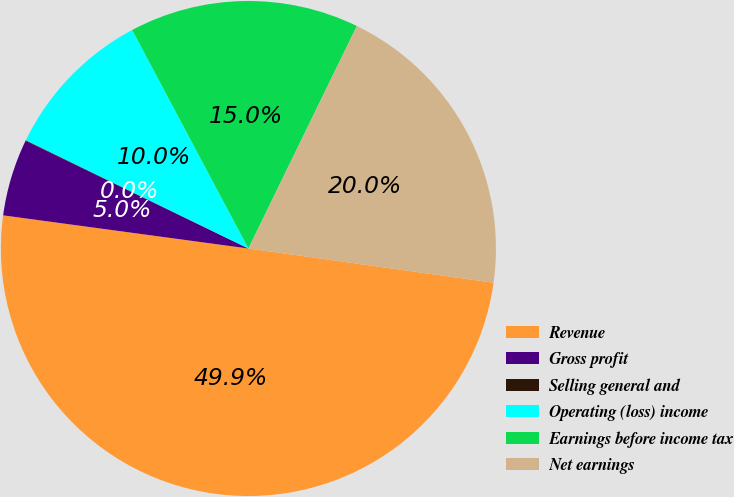Convert chart to OTSL. <chart><loc_0><loc_0><loc_500><loc_500><pie_chart><fcel>Revenue<fcel>Gross profit<fcel>Selling general and<fcel>Operating (loss) income<fcel>Earnings before income tax<fcel>Net earnings<nl><fcel>49.93%<fcel>5.03%<fcel>0.04%<fcel>10.01%<fcel>15.0%<fcel>19.99%<nl></chart> 